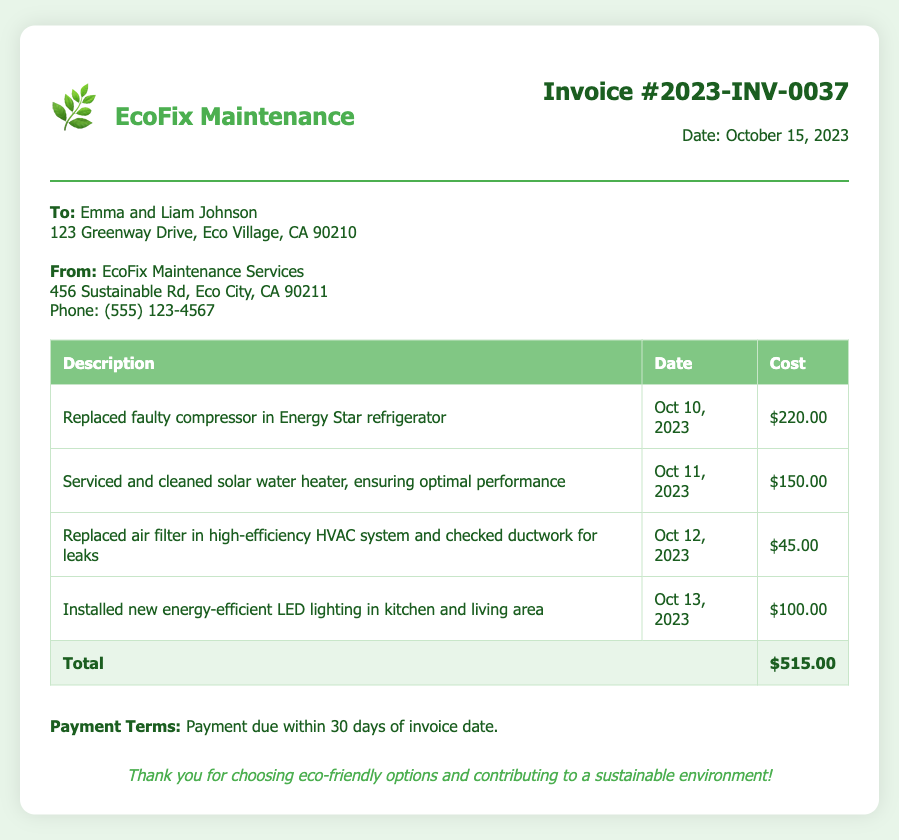what is the invoice number? The invoice number is clearly stated at the top of the document under the invoice details section.
Answer: 2023-INV-0037 what is the total cost for services performed? The total cost is calculated by summing the individual costs listed in the table, which amounts to $515.00.
Answer: $515.00 who performed the maintenance services? The maintenance services were performed by EcoFix Maintenance Services, as noted in the document.
Answer: EcoFix Maintenance Services when was the faulty compressor replaced? The date for the replacement of the faulty compressor in the refrigerator is listed in the description of services.
Answer: Oct 10, 2023 how many services are listed in the invoice? The number of services can be counted in the table where each service is described, totaling four entries.
Answer: 4 what type of payment terms are mentioned? The payment terms detail the timeframe for payment as specified in the footer of the document.
Answer: Payment due within 30 days of invoice date what type of lighting was installed? The type of lighting installed is indicated in the description of the services performed.
Answer: energy-efficient LED lighting who is the invoice addressed to? The "To" section of the document clearly identifies the individuals to whom the invoice is issued.
Answer: Emma and Liam Johnson what service involved the solar water heater? The specific service involving the solar water heater is detailed in the table of repair services provided.
Answer: Serviced and cleaned solar water heater 